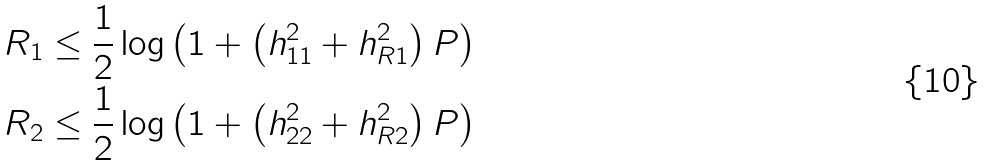Convert formula to latex. <formula><loc_0><loc_0><loc_500><loc_500>R _ { 1 } \leq \frac { 1 } { 2 } \log \left ( 1 + \left ( h _ { 1 1 } ^ { 2 } + h _ { R 1 } ^ { 2 } \right ) P \right ) \\ R _ { 2 } \leq \frac { 1 } { 2 } \log \left ( 1 + \left ( h _ { 2 2 } ^ { 2 } + h _ { R 2 } ^ { 2 } \right ) P \right )</formula> 